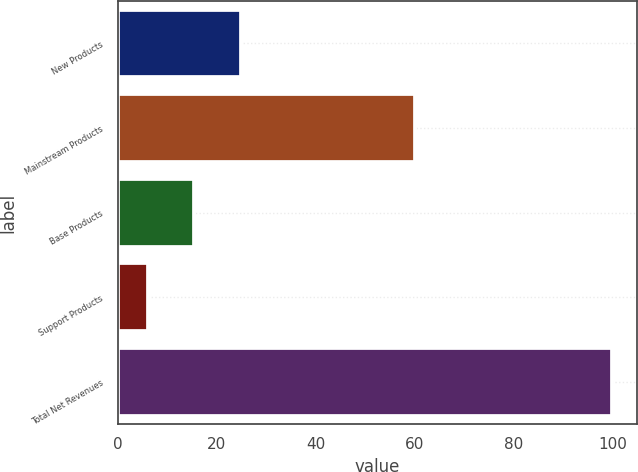Convert chart to OTSL. <chart><loc_0><loc_0><loc_500><loc_500><bar_chart><fcel>New Products<fcel>Mainstream Products<fcel>Base Products<fcel>Support Products<fcel>Total Net Revenues<nl><fcel>24.8<fcel>60<fcel>15.4<fcel>6<fcel>100<nl></chart> 